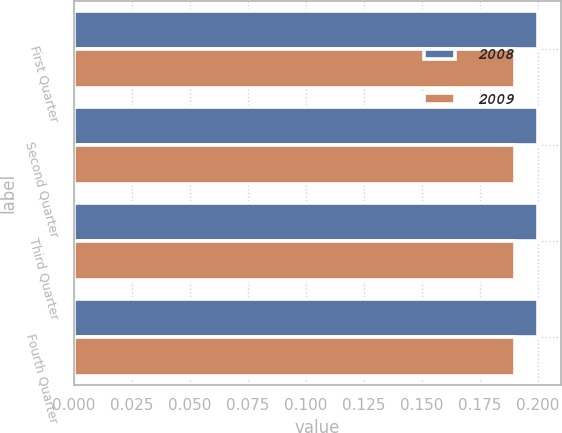Convert chart. <chart><loc_0><loc_0><loc_500><loc_500><stacked_bar_chart><ecel><fcel>First Quarter<fcel>Second Quarter<fcel>Third Quarter<fcel>Fourth Quarter<nl><fcel>2008<fcel>0.2<fcel>0.2<fcel>0.2<fcel>0.2<nl><fcel>2009<fcel>0.19<fcel>0.19<fcel>0.19<fcel>0.19<nl></chart> 